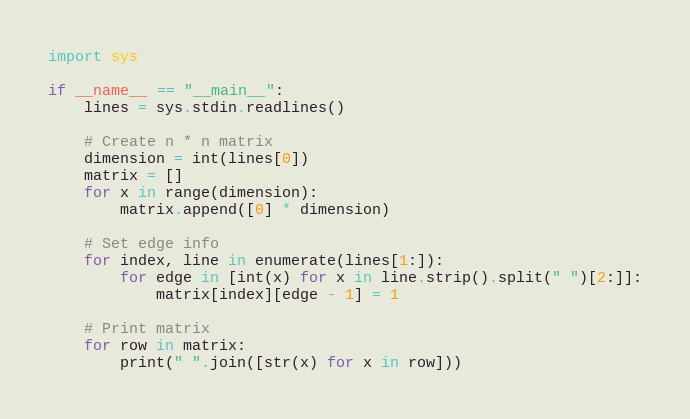Convert code to text. <code><loc_0><loc_0><loc_500><loc_500><_Python_>import sys

if __name__ == "__main__":
    lines = sys.stdin.readlines()

    # Create n * n matrix
    dimension = int(lines[0])
    matrix = []
    for x in range(dimension):
        matrix.append([0] * dimension)

    # Set edge info
    for index, line in enumerate(lines[1:]):
        for edge in [int(x) for x in line.strip().split(" ")[2:]]:
            matrix[index][edge - 1] = 1

    # Print matrix
    for row in matrix:
        print(" ".join([str(x) for x in row]))</code> 